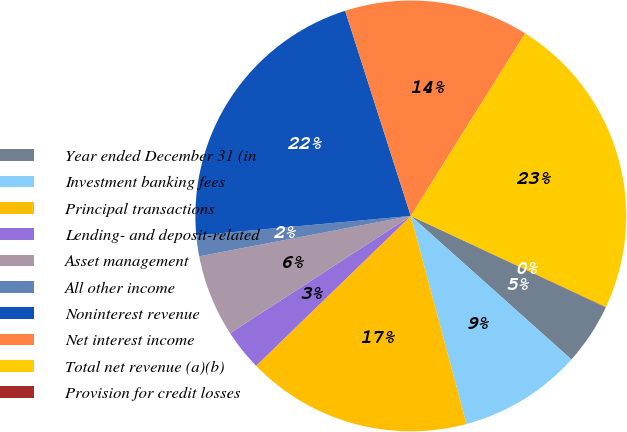<chart> <loc_0><loc_0><loc_500><loc_500><pie_chart><fcel>Year ended December 31 (in<fcel>Investment banking fees<fcel>Principal transactions<fcel>Lending- and deposit-related<fcel>Asset management<fcel>All other income<fcel>Noninterest revenue<fcel>Net interest income<fcel>Total net revenue (a)(b)<fcel>Provision for credit losses<nl><fcel>4.63%<fcel>9.23%<fcel>16.91%<fcel>3.09%<fcel>6.16%<fcel>1.56%<fcel>21.52%<fcel>13.84%<fcel>23.05%<fcel>0.02%<nl></chart> 